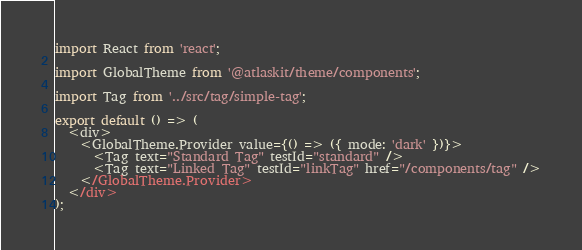<code> <loc_0><loc_0><loc_500><loc_500><_TypeScript_>import React from 'react';

import GlobalTheme from '@atlaskit/theme/components';

import Tag from '../src/tag/simple-tag';

export default () => (
  <div>
    <GlobalTheme.Provider value={() => ({ mode: 'dark' })}>
      <Tag text="Standard Tag" testId="standard" />
      <Tag text="Linked Tag" testId="linkTag" href="/components/tag" />
    </GlobalTheme.Provider>
  </div>
);
</code> 